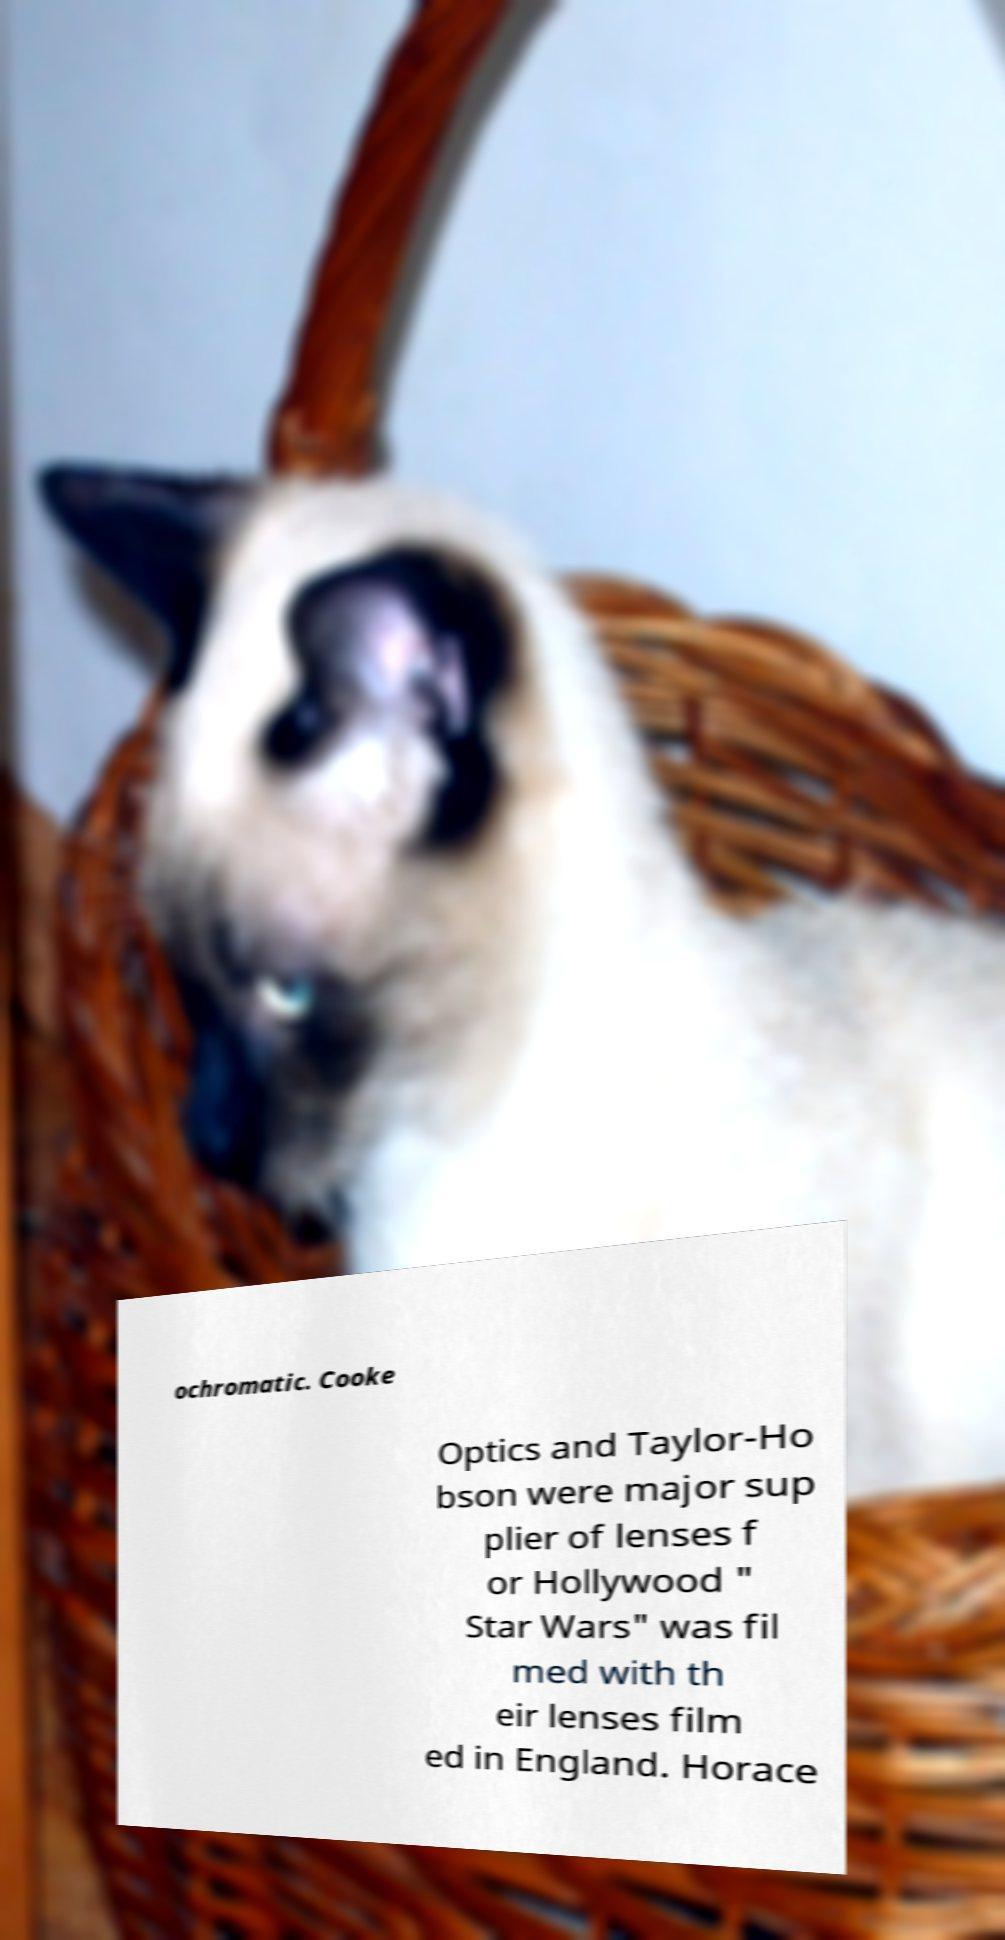There's text embedded in this image that I need extracted. Can you transcribe it verbatim? ochromatic. Cooke Optics and Taylor-Ho bson were major sup plier of lenses f or Hollywood " Star Wars" was fil med with th eir lenses film ed in England. Horace 